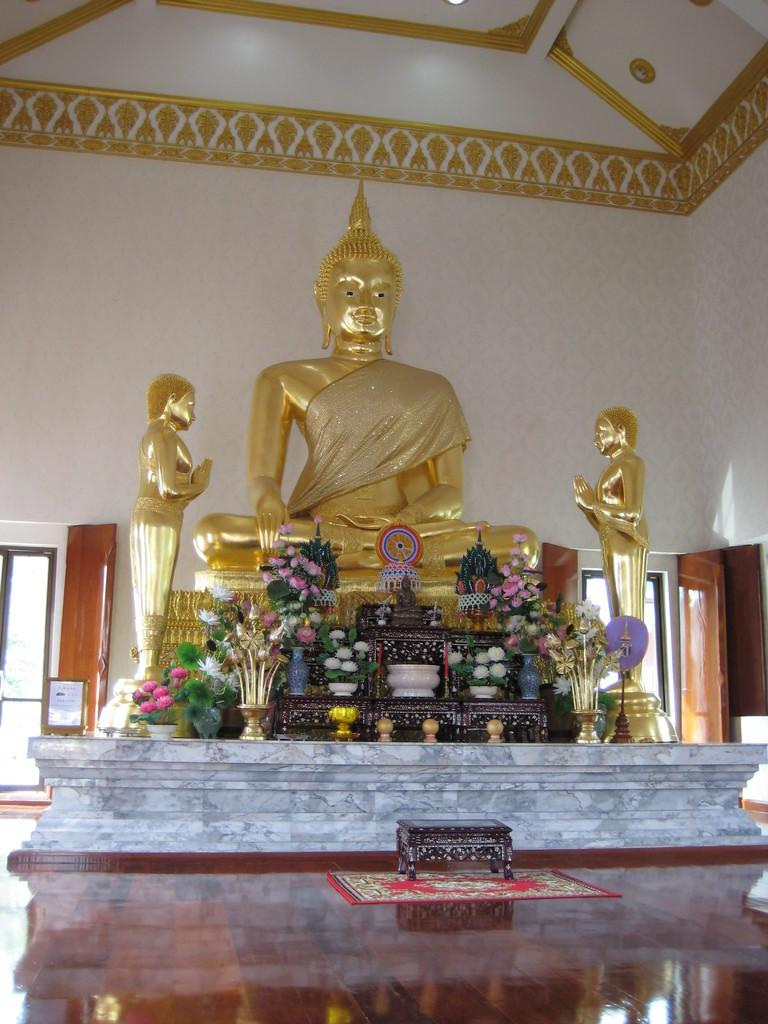What type of objects can be seen in the image? There are statues and flower pots in the image. What can be seen in the background of the image? There is a wall and doors visible in the background of the image. Can you see a goat stretching in the image? There is no goat or stretching activity present in the image. 